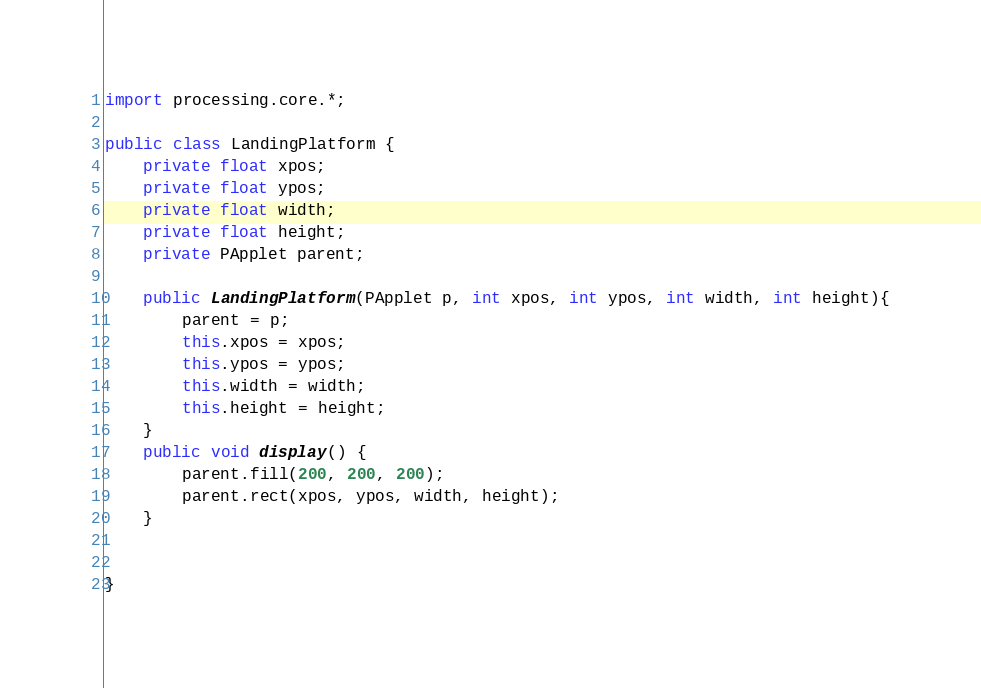<code> <loc_0><loc_0><loc_500><loc_500><_Java_>import processing.core.*;

public class LandingPlatform {
	private float xpos;
	private float ypos;
	private float width;
	private float height;
	private PApplet parent;
	
	public LandingPlatform(PApplet p, int xpos, int ypos, int width, int height){
		parent = p;
		this.xpos = xpos;
		this.ypos = ypos;
		this.width = width;
		this.height = height;
	}
	public void display() {
		parent.fill(200, 200, 200);
		parent.rect(xpos, ypos, width, height);
	}
	

}
</code> 